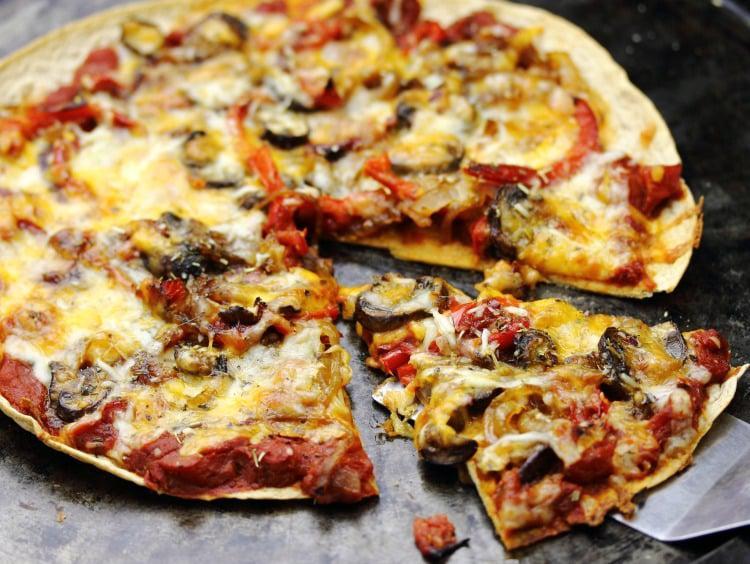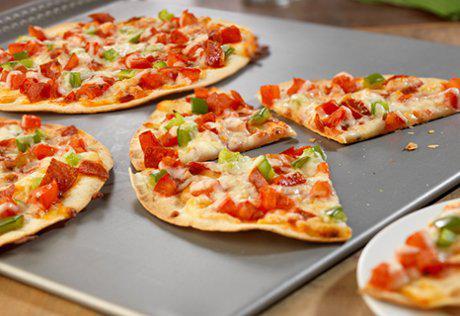The first image is the image on the left, the second image is the image on the right. Evaluate the accuracy of this statement regarding the images: "There at least two separate single slices of pizza sitting on a tray.". Is it true? Answer yes or no. Yes. The first image is the image on the left, the second image is the image on the right. Analyze the images presented: Is the assertion "A single slice is pulled away from the otherwise whole pizza in the image on the left." valid? Answer yes or no. Yes. 